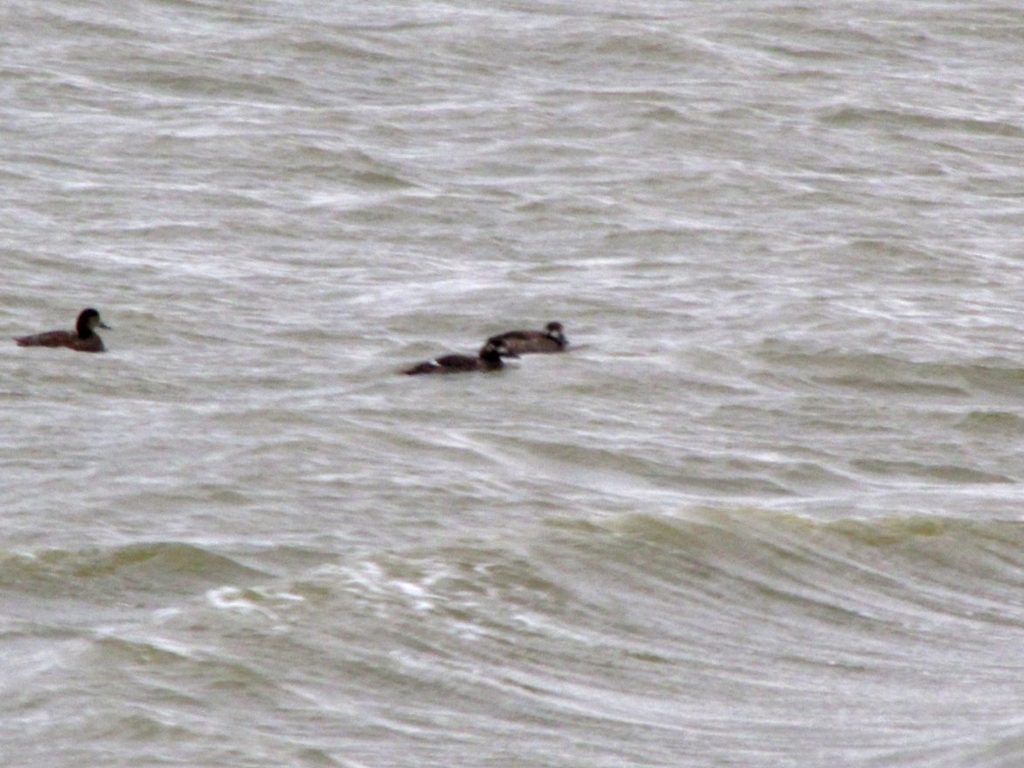What kind of ducks are these? It's difficult to determine the exact species of ducks from this image due to the distance and lack of clarity. However, considering the size and shape, they could be a common variety such as mallards or a similar dabbling duck species that frequents large bodies of water. Why is identifying ducks important? Identifying different species of ducks is important for ecological research, conservation efforts, and understanding biodiversity. Each species has unique behaviors and roles within an ecosystem, and identifying them helps us monitor their populations and health. 